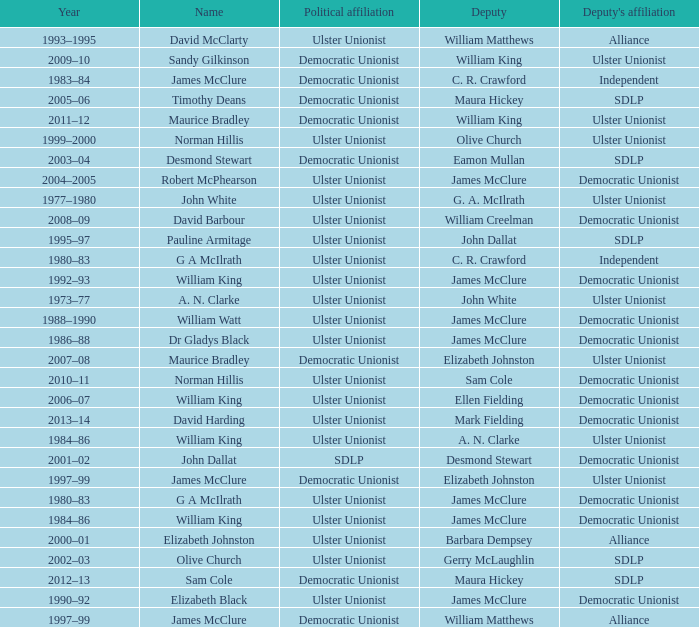What is the name of the Deputy when the Name was elizabeth black? James McClure. 